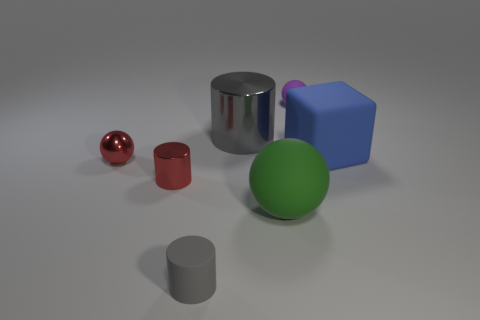There is a thing that is behind the tiny red cylinder and left of the tiny rubber cylinder; how big is it?
Give a very brief answer. Small. How many matte things are tiny cylinders or purple objects?
Give a very brief answer. 2. There is a big object in front of the small red ball; is its shape the same as the large gray shiny thing that is on the left side of the green object?
Provide a succinct answer. No. Are there any tiny spheres made of the same material as the tiny gray thing?
Ensure brevity in your answer.  Yes. The metallic ball has what color?
Provide a succinct answer. Red. How big is the metallic cylinder to the right of the tiny gray cylinder?
Your answer should be compact. Large. How many metallic things are the same color as the metal sphere?
Offer a very short reply. 1. There is a tiny red object on the left side of the small red cylinder; is there a red metallic thing on the right side of it?
Keep it short and to the point. Yes. Does the metallic ball on the left side of the big metal cylinder have the same color as the matte thing that is behind the large blue thing?
Your answer should be compact. No. What color is the metallic cylinder that is the same size as the purple matte ball?
Your answer should be very brief. Red. 